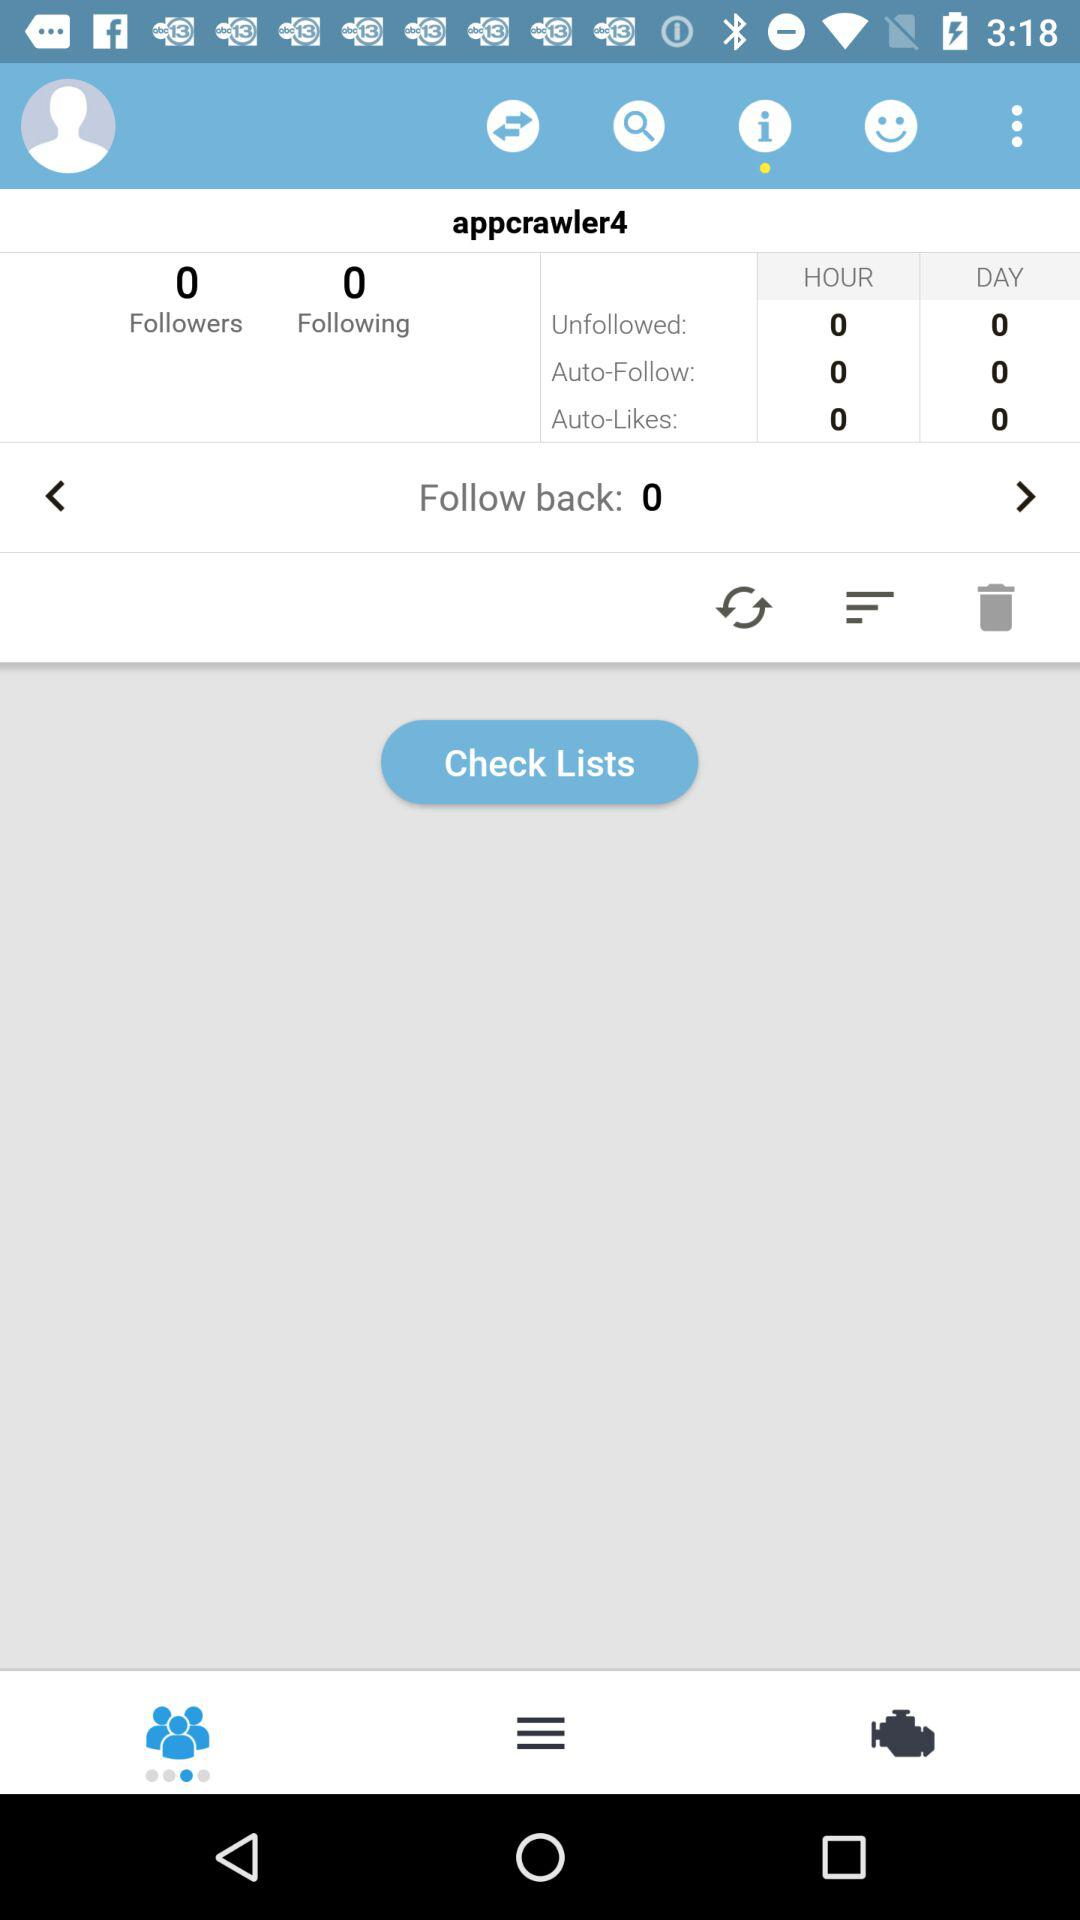How many people is "appcrawler4" following? The number of people is 0. 